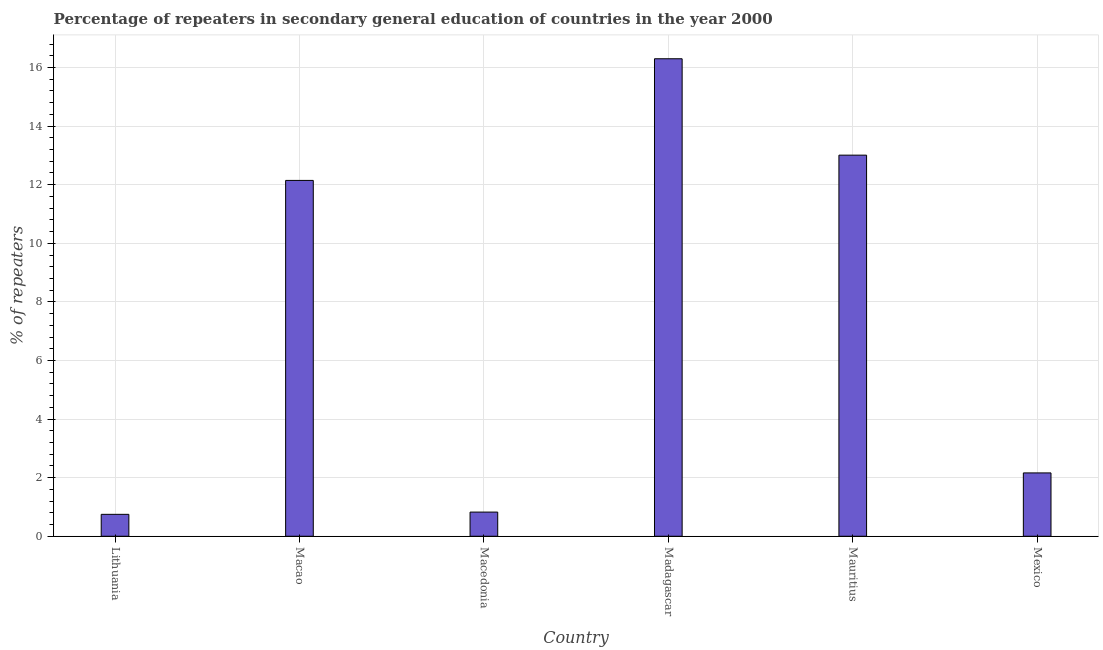Does the graph contain grids?
Make the answer very short. Yes. What is the title of the graph?
Provide a succinct answer. Percentage of repeaters in secondary general education of countries in the year 2000. What is the label or title of the Y-axis?
Offer a very short reply. % of repeaters. What is the percentage of repeaters in Mexico?
Make the answer very short. 2.16. Across all countries, what is the maximum percentage of repeaters?
Offer a terse response. 16.3. Across all countries, what is the minimum percentage of repeaters?
Provide a succinct answer. 0.75. In which country was the percentage of repeaters maximum?
Make the answer very short. Madagascar. In which country was the percentage of repeaters minimum?
Give a very brief answer. Lithuania. What is the sum of the percentage of repeaters?
Your answer should be compact. 45.19. What is the difference between the percentage of repeaters in Lithuania and Mexico?
Offer a very short reply. -1.41. What is the average percentage of repeaters per country?
Offer a terse response. 7.53. What is the median percentage of repeaters?
Your response must be concise. 7.15. What is the ratio of the percentage of repeaters in Lithuania to that in Madagascar?
Provide a succinct answer. 0.05. Is the difference between the percentage of repeaters in Macao and Madagascar greater than the difference between any two countries?
Offer a terse response. No. What is the difference between the highest and the second highest percentage of repeaters?
Offer a very short reply. 3.29. What is the difference between the highest and the lowest percentage of repeaters?
Ensure brevity in your answer.  15.55. In how many countries, is the percentage of repeaters greater than the average percentage of repeaters taken over all countries?
Offer a terse response. 3. Are all the bars in the graph horizontal?
Your answer should be compact. No. How many countries are there in the graph?
Your answer should be very brief. 6. What is the difference between two consecutive major ticks on the Y-axis?
Your answer should be compact. 2. What is the % of repeaters in Lithuania?
Ensure brevity in your answer.  0.75. What is the % of repeaters in Macao?
Your answer should be very brief. 12.15. What is the % of repeaters of Macedonia?
Ensure brevity in your answer.  0.83. What is the % of repeaters in Madagascar?
Your response must be concise. 16.3. What is the % of repeaters in Mauritius?
Make the answer very short. 13.01. What is the % of repeaters of Mexico?
Your answer should be very brief. 2.16. What is the difference between the % of repeaters in Lithuania and Macao?
Ensure brevity in your answer.  -11.4. What is the difference between the % of repeaters in Lithuania and Macedonia?
Keep it short and to the point. -0.08. What is the difference between the % of repeaters in Lithuania and Madagascar?
Give a very brief answer. -15.55. What is the difference between the % of repeaters in Lithuania and Mauritius?
Your answer should be very brief. -12.26. What is the difference between the % of repeaters in Lithuania and Mexico?
Your response must be concise. -1.41. What is the difference between the % of repeaters in Macao and Macedonia?
Your answer should be very brief. 11.32. What is the difference between the % of repeaters in Macao and Madagascar?
Your response must be concise. -4.15. What is the difference between the % of repeaters in Macao and Mauritius?
Provide a short and direct response. -0.86. What is the difference between the % of repeaters in Macao and Mexico?
Ensure brevity in your answer.  9.98. What is the difference between the % of repeaters in Macedonia and Madagascar?
Offer a very short reply. -15.47. What is the difference between the % of repeaters in Macedonia and Mauritius?
Your response must be concise. -12.18. What is the difference between the % of repeaters in Macedonia and Mexico?
Offer a terse response. -1.34. What is the difference between the % of repeaters in Madagascar and Mauritius?
Give a very brief answer. 3.29. What is the difference between the % of repeaters in Madagascar and Mexico?
Give a very brief answer. 14.14. What is the difference between the % of repeaters in Mauritius and Mexico?
Keep it short and to the point. 10.85. What is the ratio of the % of repeaters in Lithuania to that in Macao?
Keep it short and to the point. 0.06. What is the ratio of the % of repeaters in Lithuania to that in Macedonia?
Your response must be concise. 0.91. What is the ratio of the % of repeaters in Lithuania to that in Madagascar?
Offer a terse response. 0.05. What is the ratio of the % of repeaters in Lithuania to that in Mauritius?
Make the answer very short. 0.06. What is the ratio of the % of repeaters in Lithuania to that in Mexico?
Your response must be concise. 0.35. What is the ratio of the % of repeaters in Macao to that in Macedonia?
Give a very brief answer. 14.72. What is the ratio of the % of repeaters in Macao to that in Madagascar?
Ensure brevity in your answer.  0.74. What is the ratio of the % of repeaters in Macao to that in Mauritius?
Your response must be concise. 0.93. What is the ratio of the % of repeaters in Macao to that in Mexico?
Provide a succinct answer. 5.62. What is the ratio of the % of repeaters in Macedonia to that in Madagascar?
Give a very brief answer. 0.05. What is the ratio of the % of repeaters in Macedonia to that in Mauritius?
Your answer should be very brief. 0.06. What is the ratio of the % of repeaters in Macedonia to that in Mexico?
Offer a very short reply. 0.38. What is the ratio of the % of repeaters in Madagascar to that in Mauritius?
Provide a succinct answer. 1.25. What is the ratio of the % of repeaters in Madagascar to that in Mexico?
Offer a very short reply. 7.54. What is the ratio of the % of repeaters in Mauritius to that in Mexico?
Your response must be concise. 6.02. 